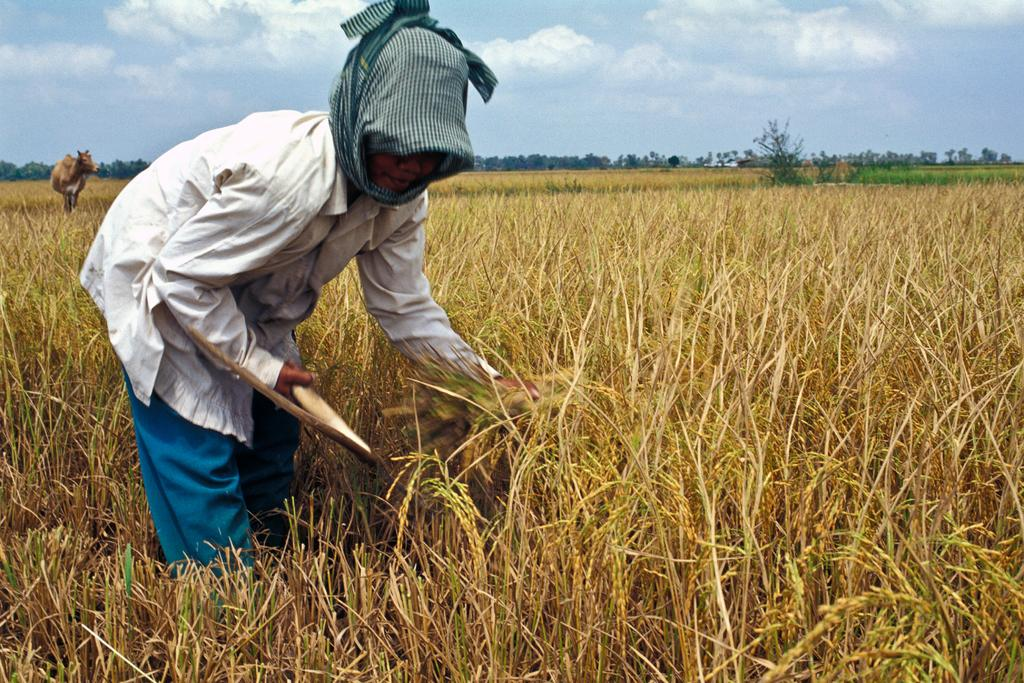What is the location of the woman in the image? The woman is on the left side of the image. What is the woman doing in the image? The woman is holding an object. What is the setting of the image? The woman is standing in a field. What can be seen in the background of the image? There are trees visible behind the woman, and clouds are visible in the image. What other living creature is present in the image? There is an animal visible in the image. What type of wire is being used to support the nest in the image? There is no wire or nest present in the image; it features a woman standing in a field with an object, trees in the background, and an animal visible. 